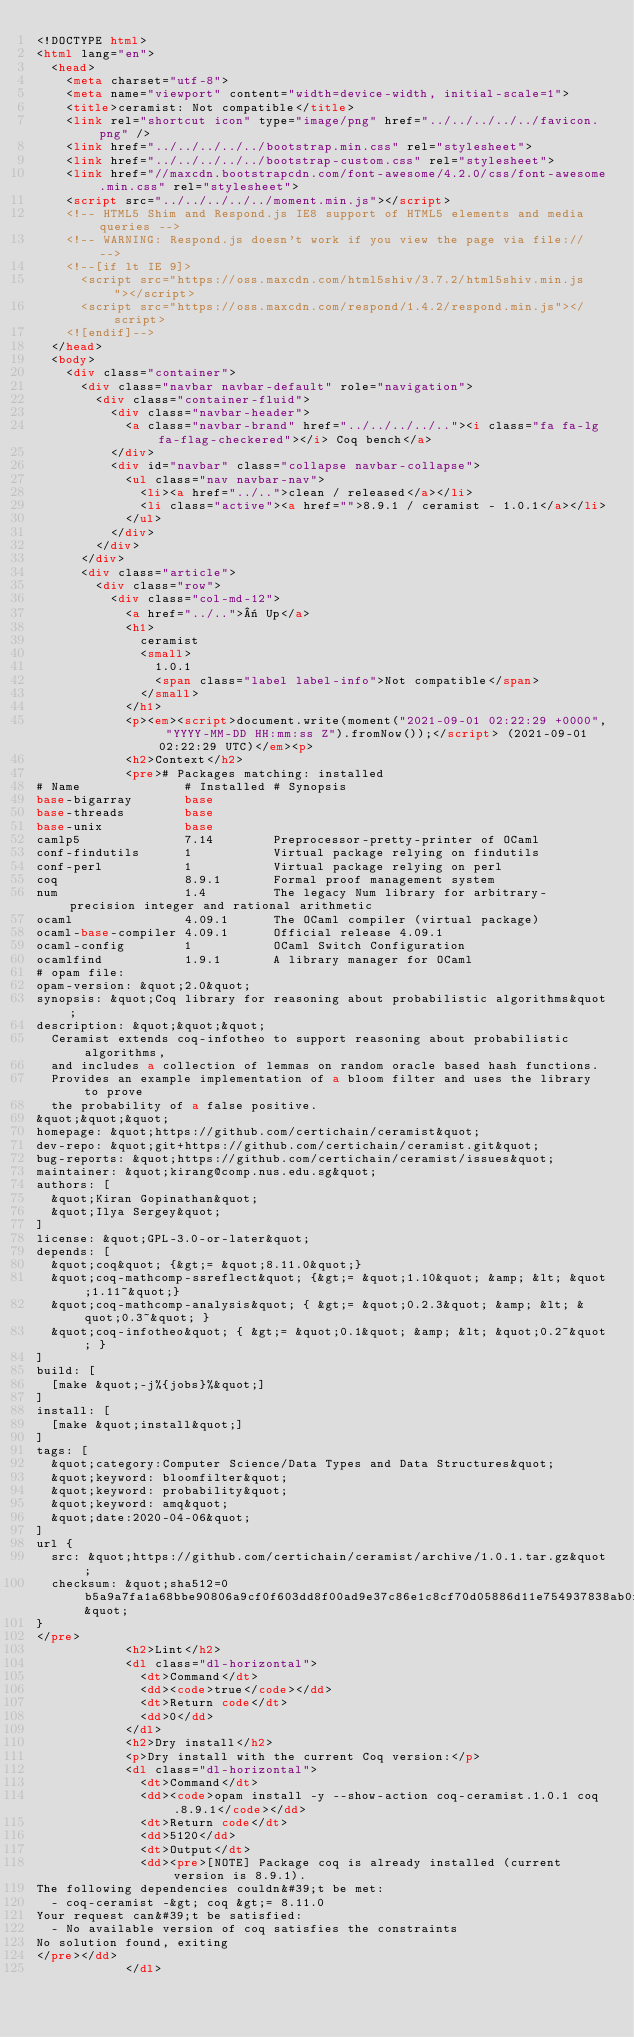Convert code to text. <code><loc_0><loc_0><loc_500><loc_500><_HTML_><!DOCTYPE html>
<html lang="en">
  <head>
    <meta charset="utf-8">
    <meta name="viewport" content="width=device-width, initial-scale=1">
    <title>ceramist: Not compatible</title>
    <link rel="shortcut icon" type="image/png" href="../../../../../favicon.png" />
    <link href="../../../../../bootstrap.min.css" rel="stylesheet">
    <link href="../../../../../bootstrap-custom.css" rel="stylesheet">
    <link href="//maxcdn.bootstrapcdn.com/font-awesome/4.2.0/css/font-awesome.min.css" rel="stylesheet">
    <script src="../../../../../moment.min.js"></script>
    <!-- HTML5 Shim and Respond.js IE8 support of HTML5 elements and media queries -->
    <!-- WARNING: Respond.js doesn't work if you view the page via file:// -->
    <!--[if lt IE 9]>
      <script src="https://oss.maxcdn.com/html5shiv/3.7.2/html5shiv.min.js"></script>
      <script src="https://oss.maxcdn.com/respond/1.4.2/respond.min.js"></script>
    <![endif]-->
  </head>
  <body>
    <div class="container">
      <div class="navbar navbar-default" role="navigation">
        <div class="container-fluid">
          <div class="navbar-header">
            <a class="navbar-brand" href="../../../../.."><i class="fa fa-lg fa-flag-checkered"></i> Coq bench</a>
          </div>
          <div id="navbar" class="collapse navbar-collapse">
            <ul class="nav navbar-nav">
              <li><a href="../..">clean / released</a></li>
              <li class="active"><a href="">8.9.1 / ceramist - 1.0.1</a></li>
            </ul>
          </div>
        </div>
      </div>
      <div class="article">
        <div class="row">
          <div class="col-md-12">
            <a href="../..">« Up</a>
            <h1>
              ceramist
              <small>
                1.0.1
                <span class="label label-info">Not compatible</span>
              </small>
            </h1>
            <p><em><script>document.write(moment("2021-09-01 02:22:29 +0000", "YYYY-MM-DD HH:mm:ss Z").fromNow());</script> (2021-09-01 02:22:29 UTC)</em><p>
            <h2>Context</h2>
            <pre># Packages matching: installed
# Name              # Installed # Synopsis
base-bigarray       base
base-threads        base
base-unix           base
camlp5              7.14        Preprocessor-pretty-printer of OCaml
conf-findutils      1           Virtual package relying on findutils
conf-perl           1           Virtual package relying on perl
coq                 8.9.1       Formal proof management system
num                 1.4         The legacy Num library for arbitrary-precision integer and rational arithmetic
ocaml               4.09.1      The OCaml compiler (virtual package)
ocaml-base-compiler 4.09.1      Official release 4.09.1
ocaml-config        1           OCaml Switch Configuration
ocamlfind           1.9.1       A library manager for OCaml
# opam file:
opam-version: &quot;2.0&quot;
synopsis: &quot;Coq library for reasoning about probabilistic algorithms&quot;
description: &quot;&quot;&quot;
  Ceramist extends coq-infotheo to support reasoning about probabilistic algorithms,
  and includes a collection of lemmas on random oracle based hash functions.
  Provides an example implementation of a bloom filter and uses the library to prove
  the probability of a false positive.
&quot;&quot;&quot;
homepage: &quot;https://github.com/certichain/ceramist&quot;
dev-repo: &quot;git+https://github.com/certichain/ceramist.git&quot;
bug-reports: &quot;https://github.com/certichain/ceramist/issues&quot;
maintainer: &quot;kirang@comp.nus.edu.sg&quot;
authors: [
  &quot;Kiran Gopinathan&quot;
  &quot;Ilya Sergey&quot;
]
license: &quot;GPL-3.0-or-later&quot;
depends: [
  &quot;coq&quot; {&gt;= &quot;8.11.0&quot;}
  &quot;coq-mathcomp-ssreflect&quot; {&gt;= &quot;1.10&quot; &amp; &lt; &quot;1.11~&quot;}
  &quot;coq-mathcomp-analysis&quot; { &gt;= &quot;0.2.3&quot; &amp; &lt; &quot;0.3~&quot; }
  &quot;coq-infotheo&quot; { &gt;= &quot;0.1&quot; &amp; &lt; &quot;0.2~&quot; }
]
build: [
  [make &quot;-j%{jobs}%&quot;]
]
install: [
  [make &quot;install&quot;]
]
tags: [
  &quot;category:Computer Science/Data Types and Data Structures&quot;
  &quot;keyword: bloomfilter&quot;
  &quot;keyword: probability&quot;
  &quot;keyword: amq&quot;
  &quot;date:2020-04-06&quot;
]
url {
  src: &quot;https://github.com/certichain/ceramist/archive/1.0.1.tar.gz&quot;
  checksum: &quot;sha512=0b5a9a7fa1a68bbe90806a9cf0f603dd8f00ad9e37c86e1c8cf70d05886d11e754937838ab0f335c04c0eb0b622c49f1f6c46509880d3f9c47769d9c159defaa&quot;
}
</pre>
            <h2>Lint</h2>
            <dl class="dl-horizontal">
              <dt>Command</dt>
              <dd><code>true</code></dd>
              <dt>Return code</dt>
              <dd>0</dd>
            </dl>
            <h2>Dry install</h2>
            <p>Dry install with the current Coq version:</p>
            <dl class="dl-horizontal">
              <dt>Command</dt>
              <dd><code>opam install -y --show-action coq-ceramist.1.0.1 coq.8.9.1</code></dd>
              <dt>Return code</dt>
              <dd>5120</dd>
              <dt>Output</dt>
              <dd><pre>[NOTE] Package coq is already installed (current version is 8.9.1).
The following dependencies couldn&#39;t be met:
  - coq-ceramist -&gt; coq &gt;= 8.11.0
Your request can&#39;t be satisfied:
  - No available version of coq satisfies the constraints
No solution found, exiting
</pre></dd>
            </dl></code> 